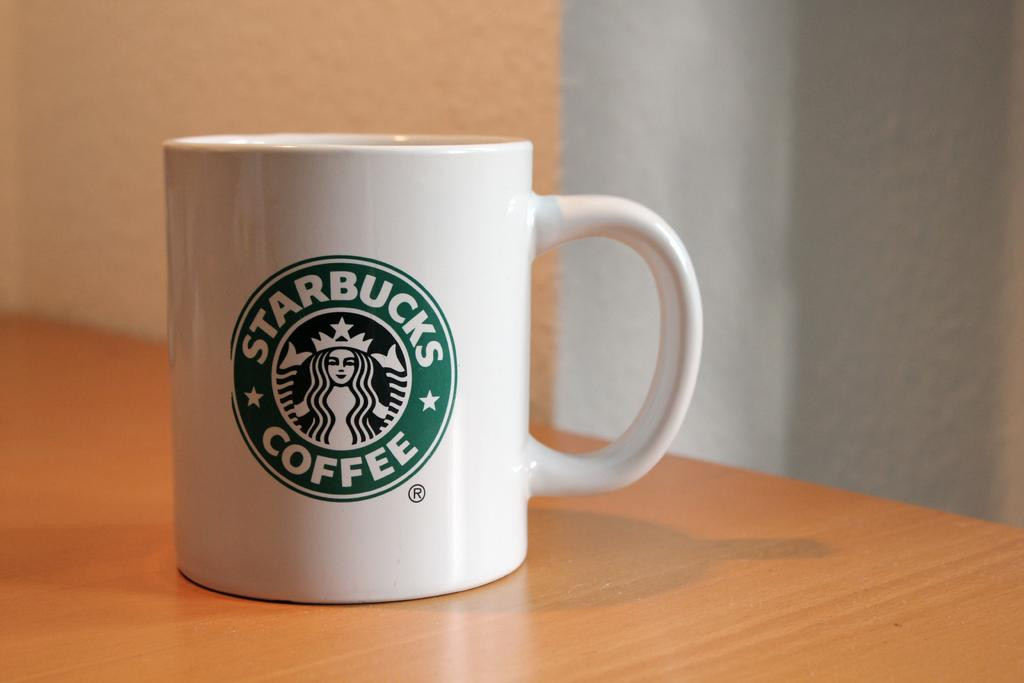What color is the cup in the image? The cup in the image is white. Is there any design or logo on the cup? Yes, the cup has a green color logo on it. What is the surface on which the cup is placed? The cup is placed on a wooden surface. What can be seen in the background of the image? There is a wall visible in the background of the image. What type of dress is the person wearing in the image? There is no person or dress present in the image; it only features a white cup with a green color logo on it. 